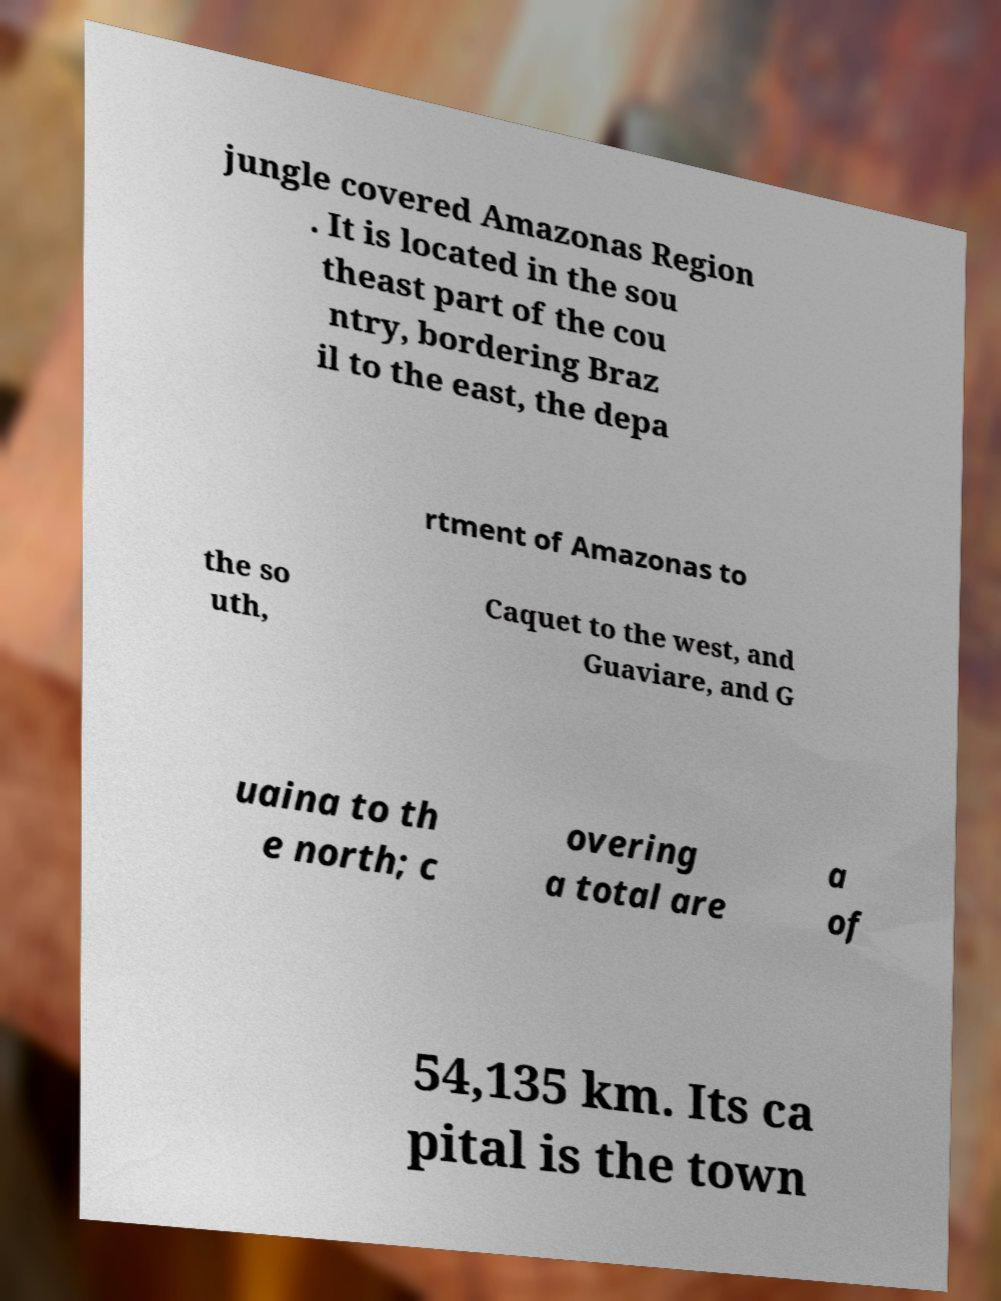Could you assist in decoding the text presented in this image and type it out clearly? jungle covered Amazonas Region . It is located in the sou theast part of the cou ntry, bordering Braz il to the east, the depa rtment of Amazonas to the so uth, Caquet to the west, and Guaviare, and G uaina to th e north; c overing a total are a of 54,135 km. Its ca pital is the town 